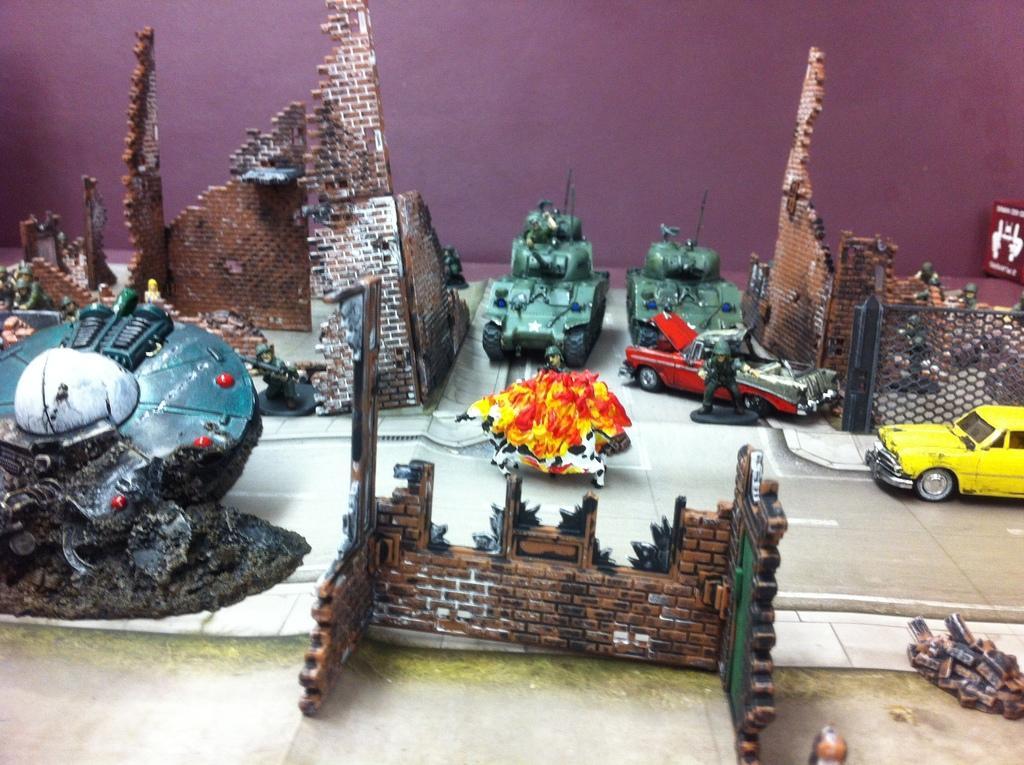Describe this image in one or two sentences. In this image we can see a group of toys on a surface. Behind the toys we can see a wall. 